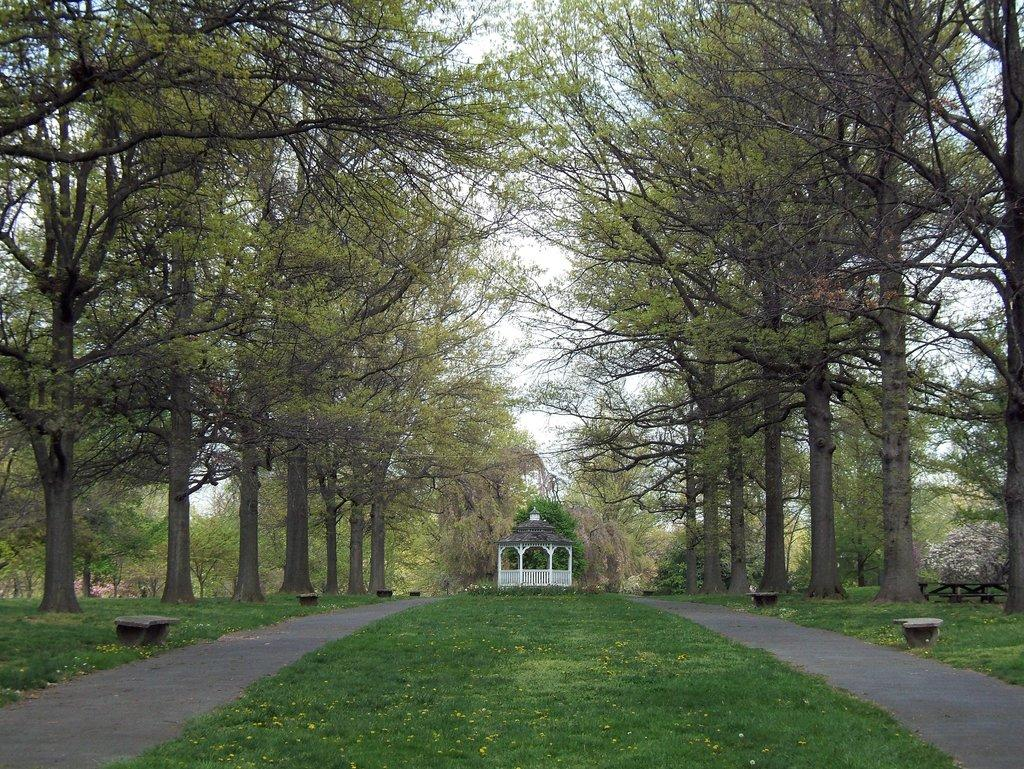What type of vegetation can be seen in the image? There are trees in the image. What type of seating is available in the image? There are benches in the image. What is the ground covered with in the image? There is grass on the ground in the image. What structure can be seen in the background of the image? There is a shelter in the background of the image. What is the condition of the sky in the image? The sky is cloudy in the image. Where is the map located in the image? There is no map present in the image. What type of cart can be seen near the benches in the image? There is no cart present in the image. 